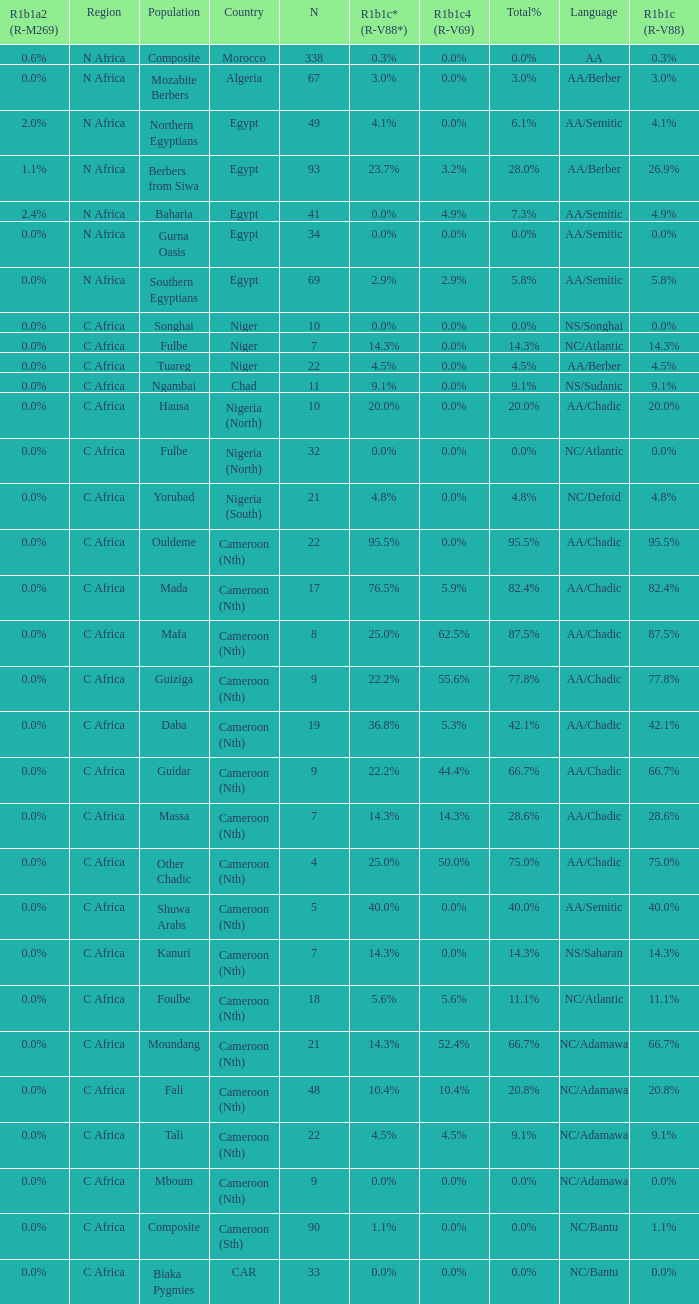Could you help me parse every detail presented in this table? {'header': ['R1b1a2 (R-M269)', 'Region', 'Population', 'Country', 'N', 'R1b1c* (R-V88*)', 'R1b1c4 (R-V69)', 'Total%', 'Language', 'R1b1c (R-V88)'], 'rows': [['0.6%', 'N Africa', 'Composite', 'Morocco', '338', '0.3%', '0.0%', '0.0%', 'AA', '0.3%'], ['0.0%', 'N Africa', 'Mozabite Berbers', 'Algeria', '67', '3.0%', '0.0%', '3.0%', 'AA/Berber', '3.0%'], ['2.0%', 'N Africa', 'Northern Egyptians', 'Egypt', '49', '4.1%', '0.0%', '6.1%', 'AA/Semitic', '4.1%'], ['1.1%', 'N Africa', 'Berbers from Siwa', 'Egypt', '93', '23.7%', '3.2%', '28.0%', 'AA/Berber', '26.9%'], ['2.4%', 'N Africa', 'Baharia', 'Egypt', '41', '0.0%', '4.9%', '7.3%', 'AA/Semitic', '4.9%'], ['0.0%', 'N Africa', 'Gurna Oasis', 'Egypt', '34', '0.0%', '0.0%', '0.0%', 'AA/Semitic', '0.0%'], ['0.0%', 'N Africa', 'Southern Egyptians', 'Egypt', '69', '2.9%', '2.9%', '5.8%', 'AA/Semitic', '5.8%'], ['0.0%', 'C Africa', 'Songhai', 'Niger', '10', '0.0%', '0.0%', '0.0%', 'NS/Songhai', '0.0%'], ['0.0%', 'C Africa', 'Fulbe', 'Niger', '7', '14.3%', '0.0%', '14.3%', 'NC/Atlantic', '14.3%'], ['0.0%', 'C Africa', 'Tuareg', 'Niger', '22', '4.5%', '0.0%', '4.5%', 'AA/Berber', '4.5%'], ['0.0%', 'C Africa', 'Ngambai', 'Chad', '11', '9.1%', '0.0%', '9.1%', 'NS/Sudanic', '9.1%'], ['0.0%', 'C Africa', 'Hausa', 'Nigeria (North)', '10', '20.0%', '0.0%', '20.0%', 'AA/Chadic', '20.0%'], ['0.0%', 'C Africa', 'Fulbe', 'Nigeria (North)', '32', '0.0%', '0.0%', '0.0%', 'NC/Atlantic', '0.0%'], ['0.0%', 'C Africa', 'Yorubad', 'Nigeria (South)', '21', '4.8%', '0.0%', '4.8%', 'NC/Defoid', '4.8%'], ['0.0%', 'C Africa', 'Ouldeme', 'Cameroon (Nth)', '22', '95.5%', '0.0%', '95.5%', 'AA/Chadic', '95.5%'], ['0.0%', 'C Africa', 'Mada', 'Cameroon (Nth)', '17', '76.5%', '5.9%', '82.4%', 'AA/Chadic', '82.4%'], ['0.0%', 'C Africa', 'Mafa', 'Cameroon (Nth)', '8', '25.0%', '62.5%', '87.5%', 'AA/Chadic', '87.5%'], ['0.0%', 'C Africa', 'Guiziga', 'Cameroon (Nth)', '9', '22.2%', '55.6%', '77.8%', 'AA/Chadic', '77.8%'], ['0.0%', 'C Africa', 'Daba', 'Cameroon (Nth)', '19', '36.8%', '5.3%', '42.1%', 'AA/Chadic', '42.1%'], ['0.0%', 'C Africa', 'Guidar', 'Cameroon (Nth)', '9', '22.2%', '44.4%', '66.7%', 'AA/Chadic', '66.7%'], ['0.0%', 'C Africa', 'Massa', 'Cameroon (Nth)', '7', '14.3%', '14.3%', '28.6%', 'AA/Chadic', '28.6%'], ['0.0%', 'C Africa', 'Other Chadic', 'Cameroon (Nth)', '4', '25.0%', '50.0%', '75.0%', 'AA/Chadic', '75.0%'], ['0.0%', 'C Africa', 'Shuwa Arabs', 'Cameroon (Nth)', '5', '40.0%', '0.0%', '40.0%', 'AA/Semitic', '40.0%'], ['0.0%', 'C Africa', 'Kanuri', 'Cameroon (Nth)', '7', '14.3%', '0.0%', '14.3%', 'NS/Saharan', '14.3%'], ['0.0%', 'C Africa', 'Foulbe', 'Cameroon (Nth)', '18', '5.6%', '5.6%', '11.1%', 'NC/Atlantic', '11.1%'], ['0.0%', 'C Africa', 'Moundang', 'Cameroon (Nth)', '21', '14.3%', '52.4%', '66.7%', 'NC/Adamawa', '66.7%'], ['0.0%', 'C Africa', 'Fali', 'Cameroon (Nth)', '48', '10.4%', '10.4%', '20.8%', 'NC/Adamawa', '20.8%'], ['0.0%', 'C Africa', 'Tali', 'Cameroon (Nth)', '22', '4.5%', '4.5%', '9.1%', 'NC/Adamawa', '9.1%'], ['0.0%', 'C Africa', 'Mboum', 'Cameroon (Nth)', '9', '0.0%', '0.0%', '0.0%', 'NC/Adamawa', '0.0%'], ['0.0%', 'C Africa', 'Composite', 'Cameroon (Sth)', '90', '1.1%', '0.0%', '0.0%', 'NC/Bantu', '1.1%'], ['0.0%', 'C Africa', 'Biaka Pygmies', 'CAR', '33', '0.0%', '0.0%', '0.0%', 'NC/Bantu', '0.0%']]} 5% overall percentage? 4.5%. 